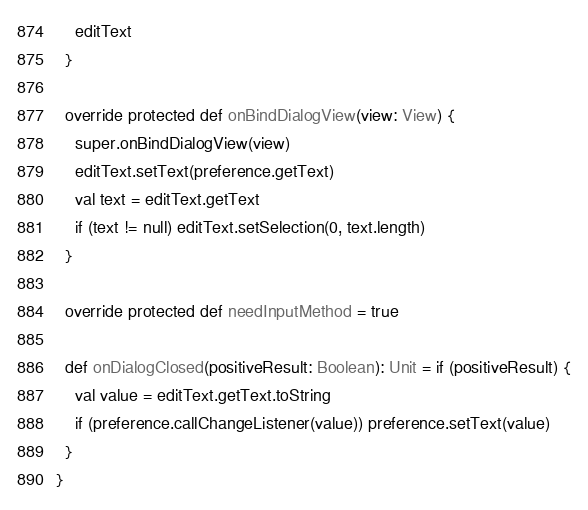Convert code to text. <code><loc_0><loc_0><loc_500><loc_500><_Scala_>    editText
  }

  override protected def onBindDialogView(view: View) {
    super.onBindDialogView(view)
    editText.setText(preference.getText)
    val text = editText.getText
    if (text != null) editText.setSelection(0, text.length)
  }

  override protected def needInputMethod = true

  def onDialogClosed(positiveResult: Boolean): Unit = if (positiveResult) {
    val value = editText.getText.toString
    if (preference.callChangeListener(value)) preference.setText(value)
  }
}
</code> 